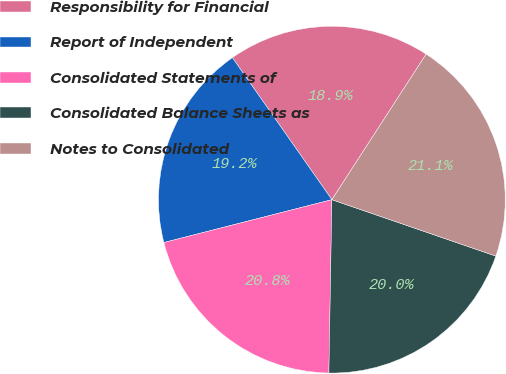<chart> <loc_0><loc_0><loc_500><loc_500><pie_chart><fcel>Responsibility for Financial<fcel>Report of Independent<fcel>Consolidated Statements of<fcel>Consolidated Balance Sheets as<fcel>Notes to Consolidated<nl><fcel>18.87%<fcel>19.25%<fcel>20.75%<fcel>20.0%<fcel>21.13%<nl></chart> 